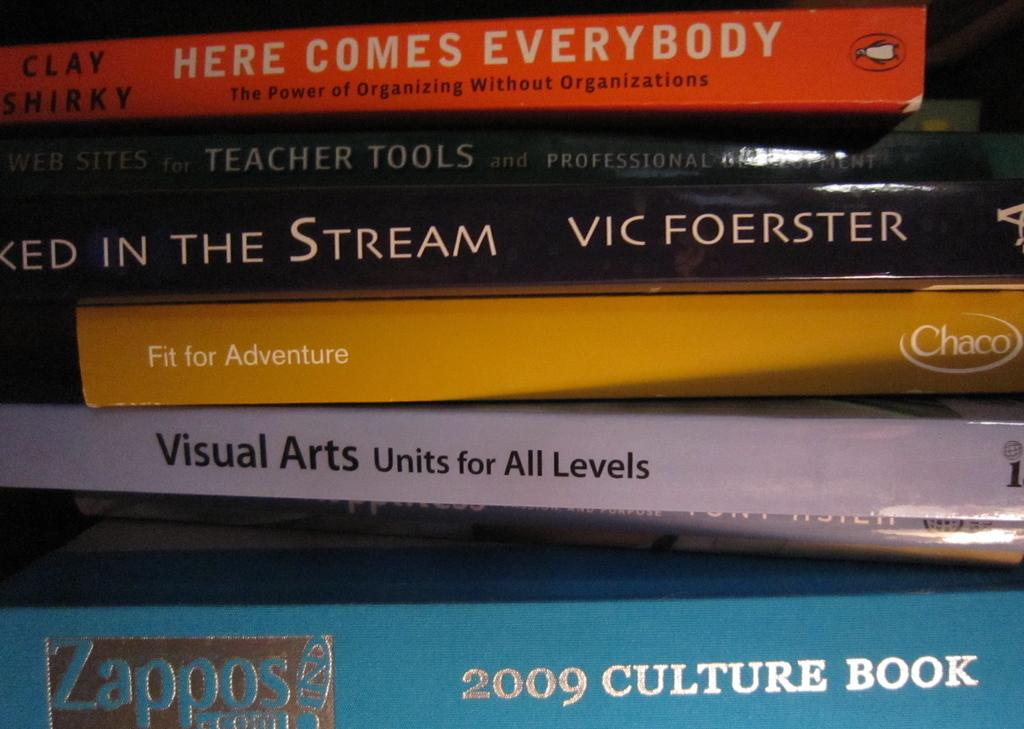<image>
Render a clear and concise summary of the photo. A stack of books with the spines showing their titles dealing with topics about teaching, learning and adventures. 